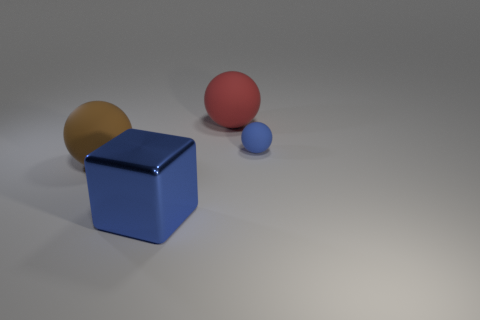Add 1 red spheres. How many objects exist? 5 Subtract all blocks. How many objects are left? 3 Subtract all blue shiny things. Subtract all blue cubes. How many objects are left? 2 Add 2 big brown things. How many big brown things are left? 3 Add 1 brown rubber spheres. How many brown rubber spheres exist? 2 Subtract 0 green balls. How many objects are left? 4 